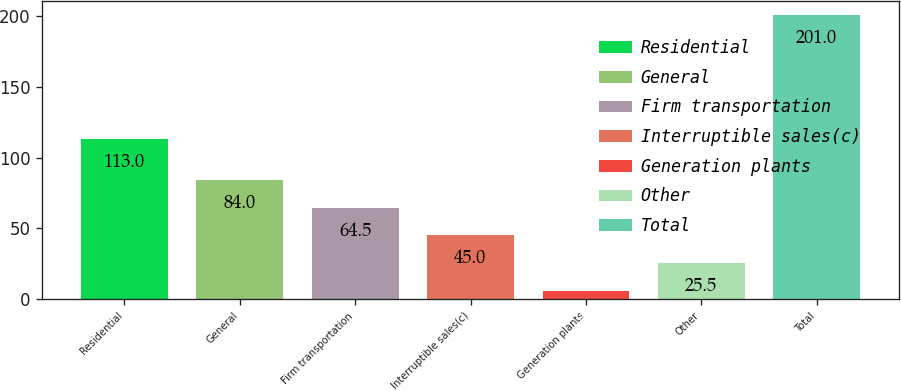Convert chart to OTSL. <chart><loc_0><loc_0><loc_500><loc_500><bar_chart><fcel>Residential<fcel>General<fcel>Firm transportation<fcel>Interruptible sales(c)<fcel>Generation plants<fcel>Other<fcel>Total<nl><fcel>113<fcel>84<fcel>64.5<fcel>45<fcel>6<fcel>25.5<fcel>201<nl></chart> 